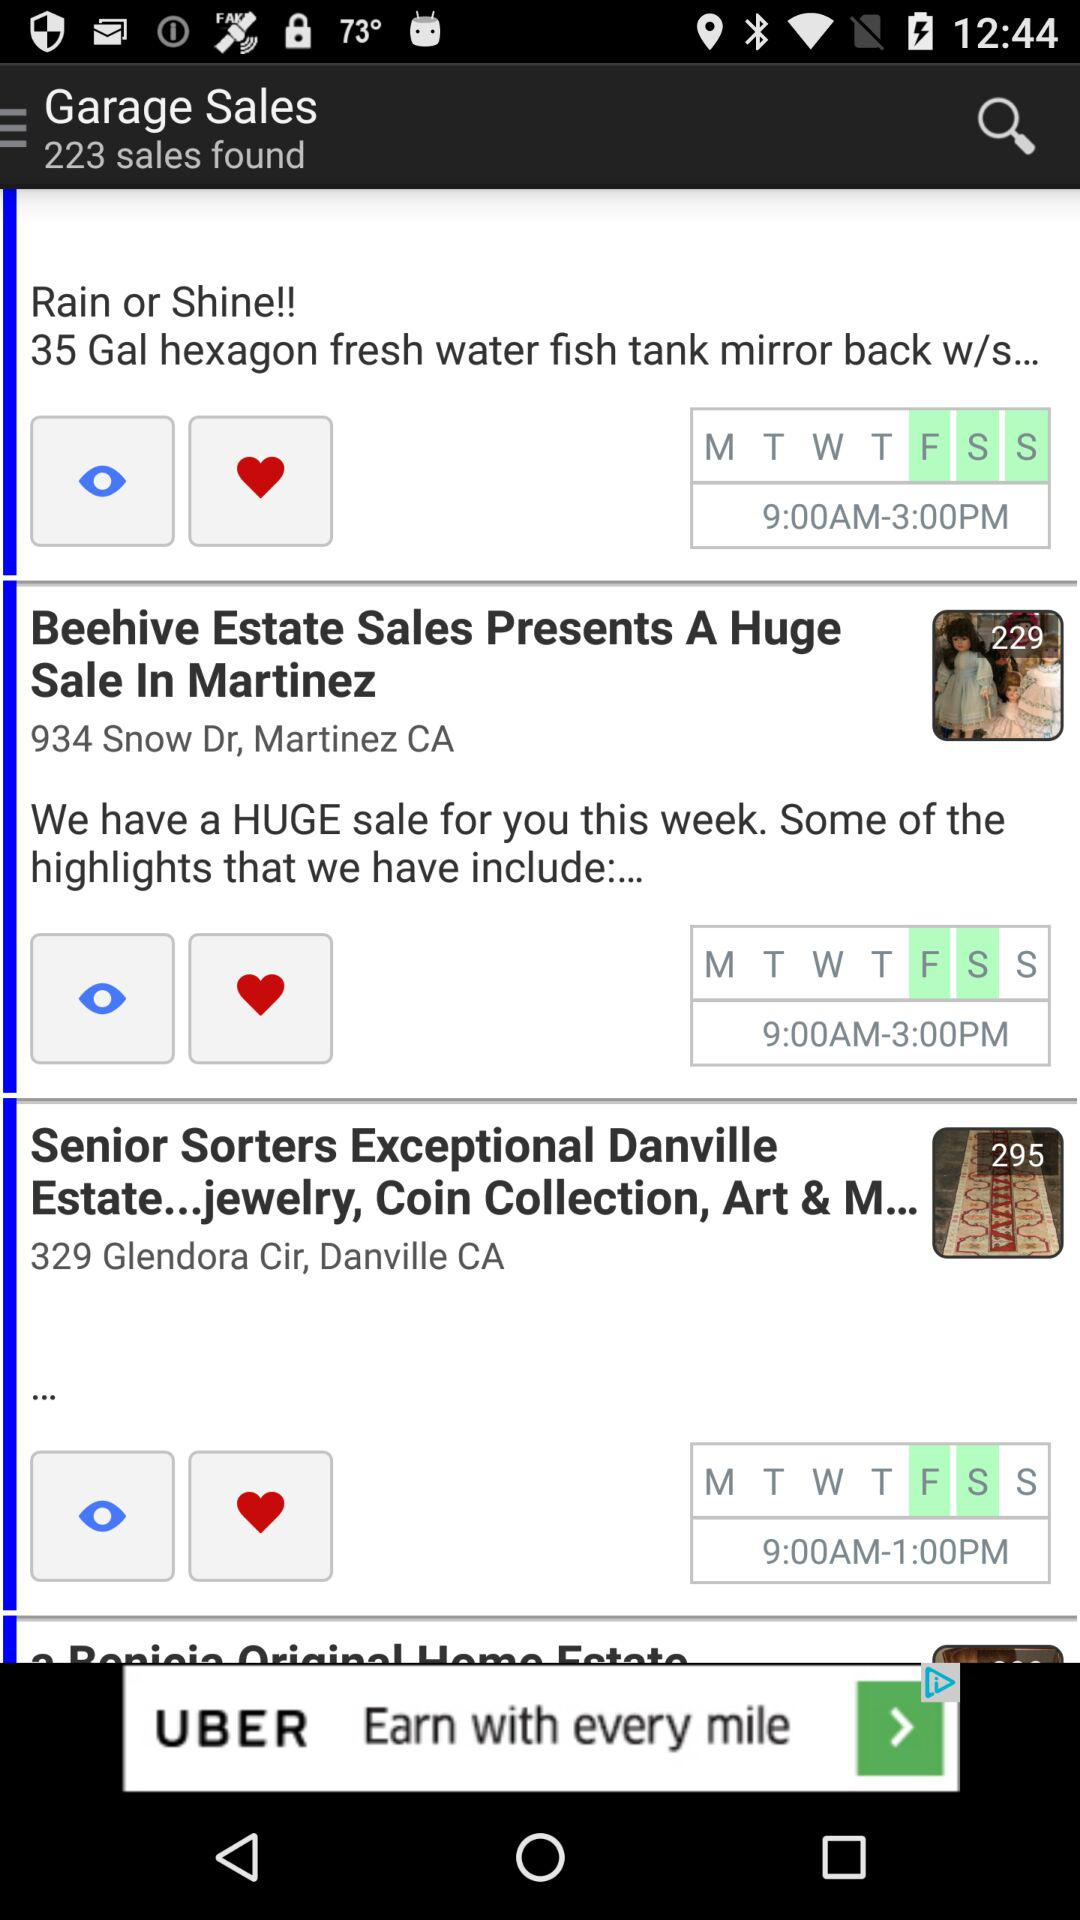What are the selected days for "Rain or Shine"? The selected days are Friday, Saturday and Sunday. 